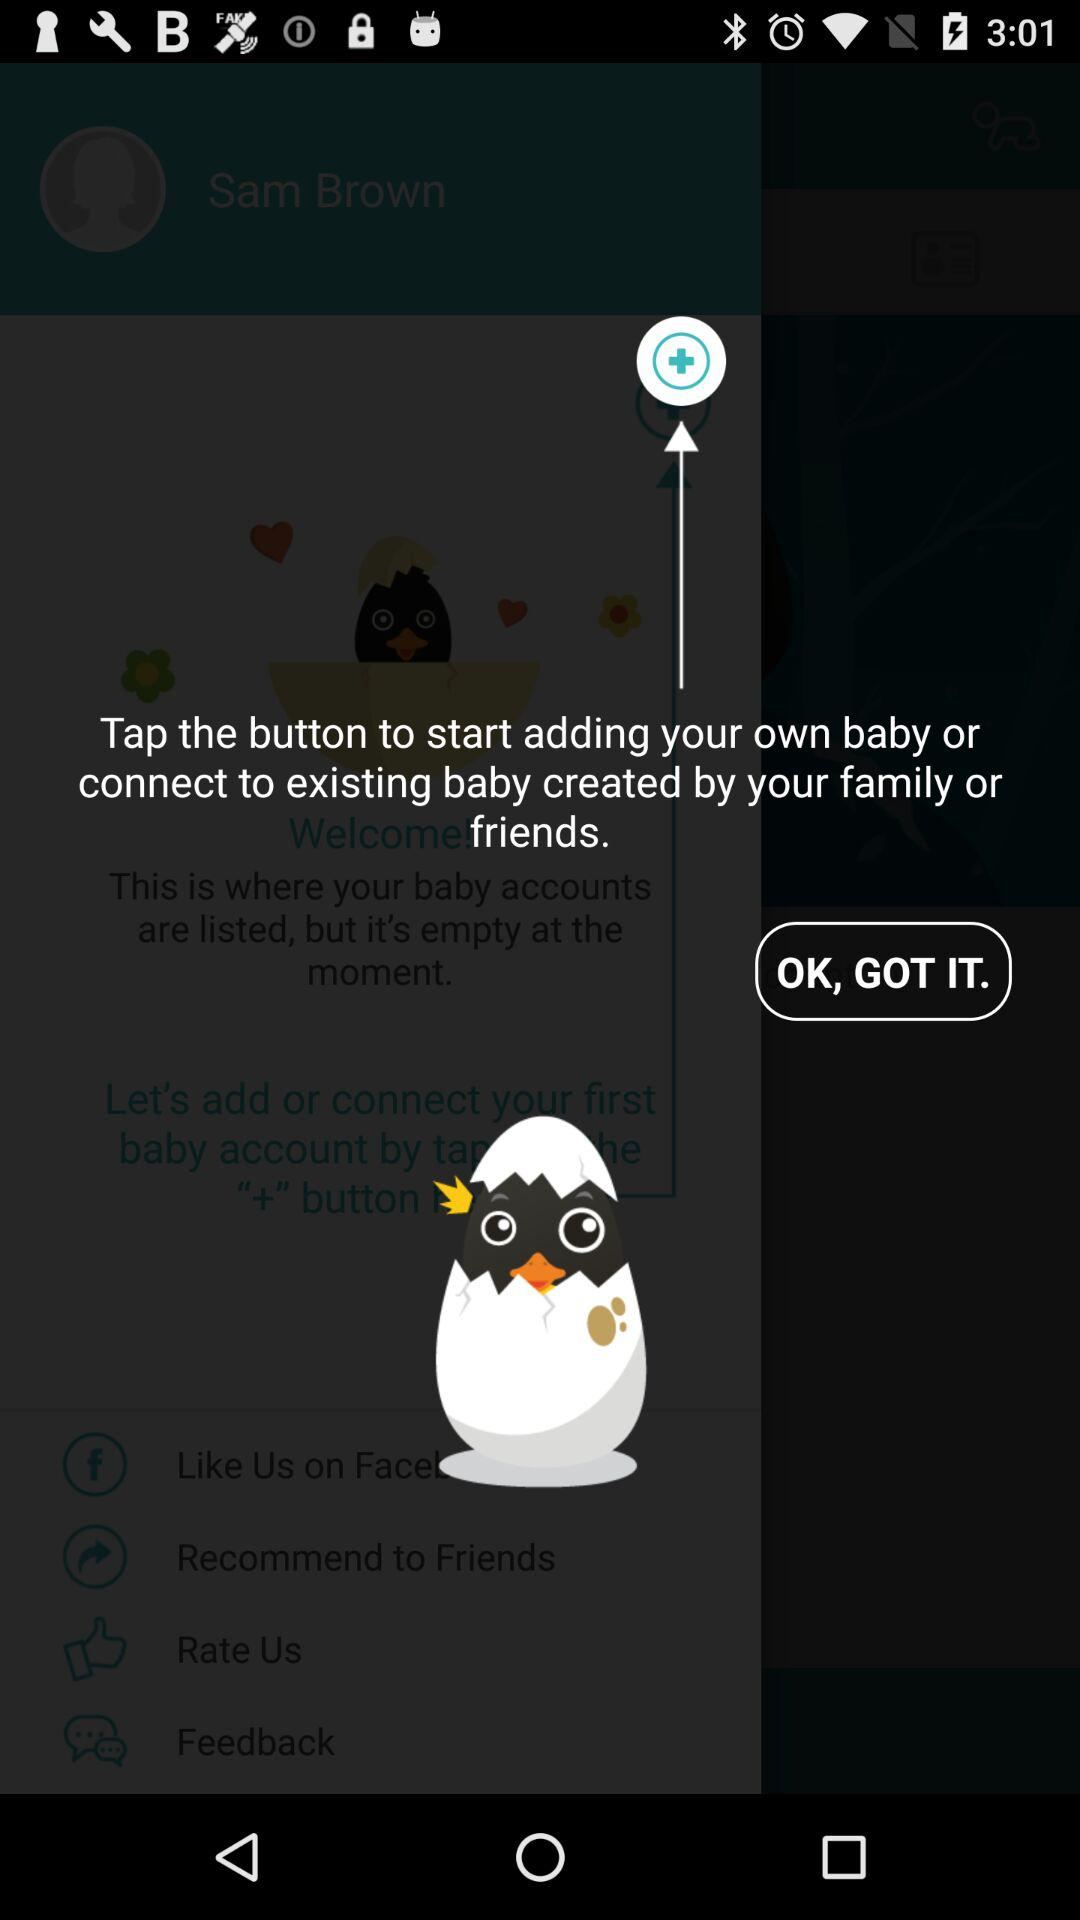What button can we use to start adding our own baby? You can use the "+" button. 